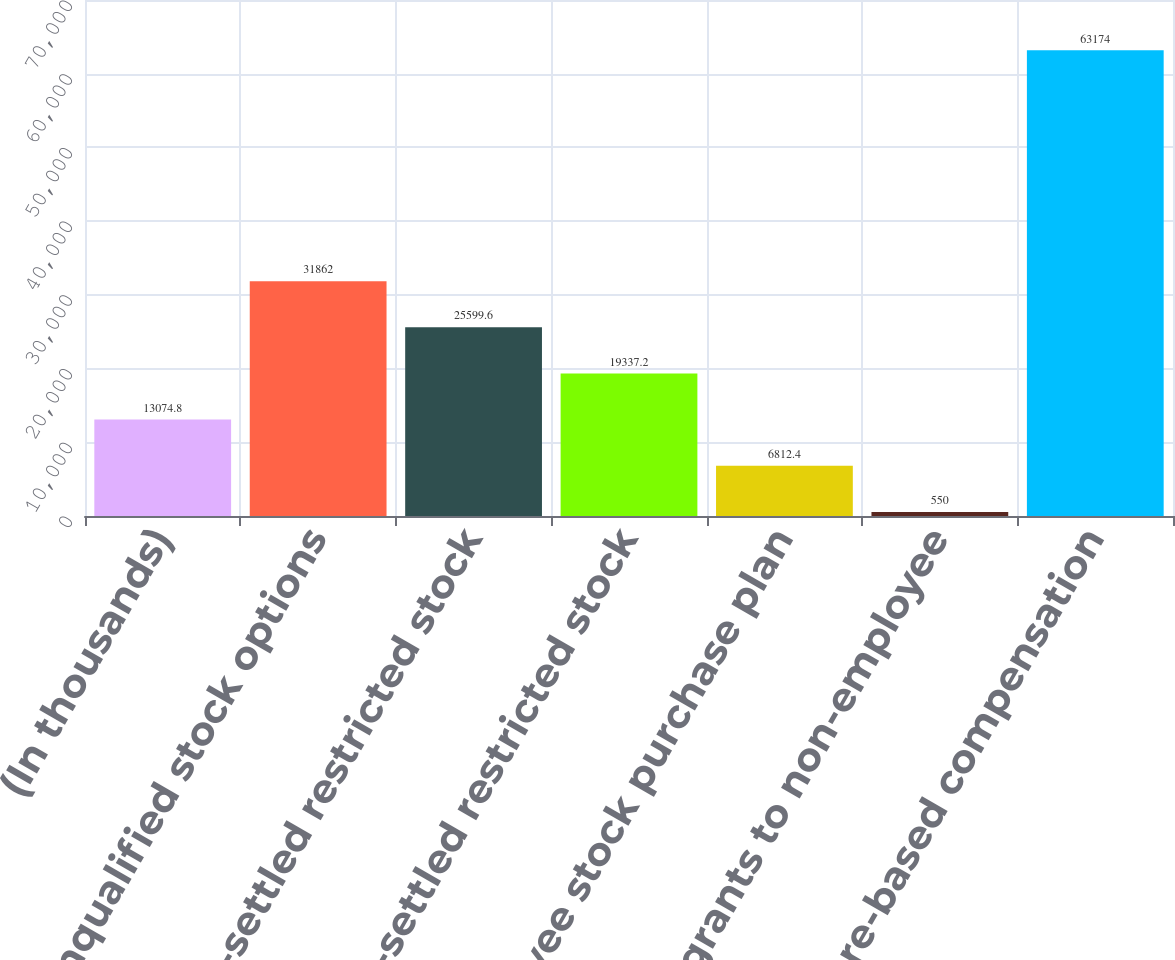<chart> <loc_0><loc_0><loc_500><loc_500><bar_chart><fcel>(In thousands)<fcel>Nonqualified stock options<fcel>Cash-settled restricted stock<fcel>Stock-settled restricted stock<fcel>Employee stock purchase plan<fcel>Stock grants to non-employee<fcel>Share-based compensation<nl><fcel>13074.8<fcel>31862<fcel>25599.6<fcel>19337.2<fcel>6812.4<fcel>550<fcel>63174<nl></chart> 